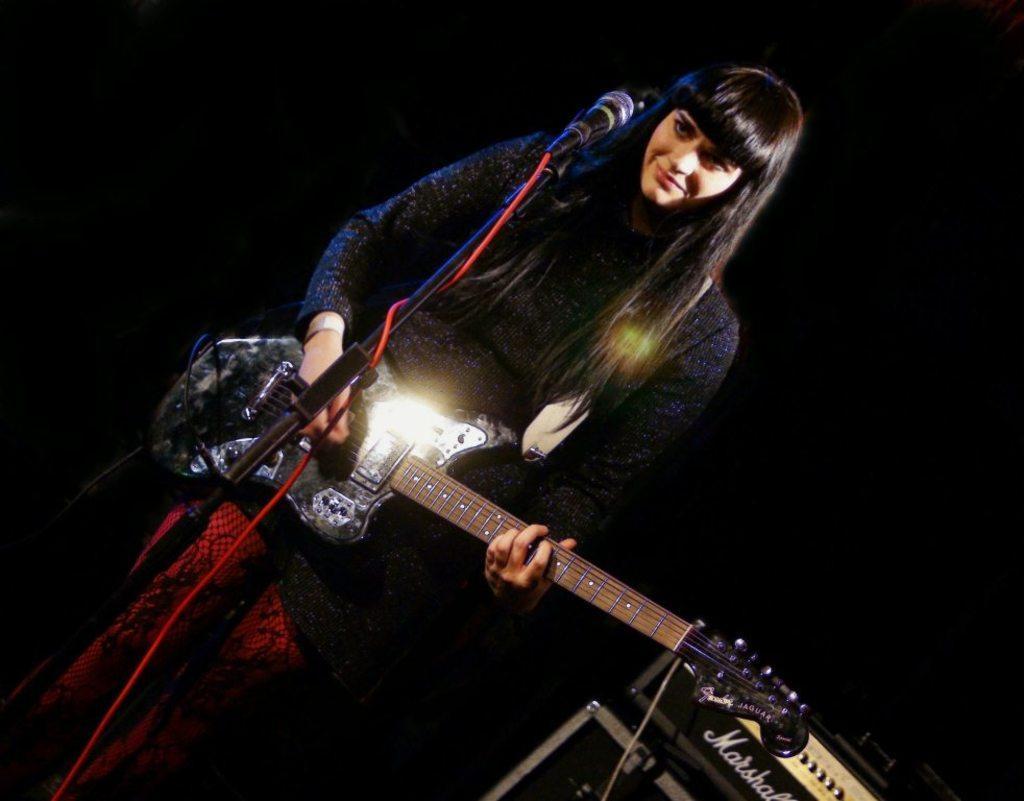How would you summarize this image in a sentence or two? A woman is playing guitar with a mic in front of her. 